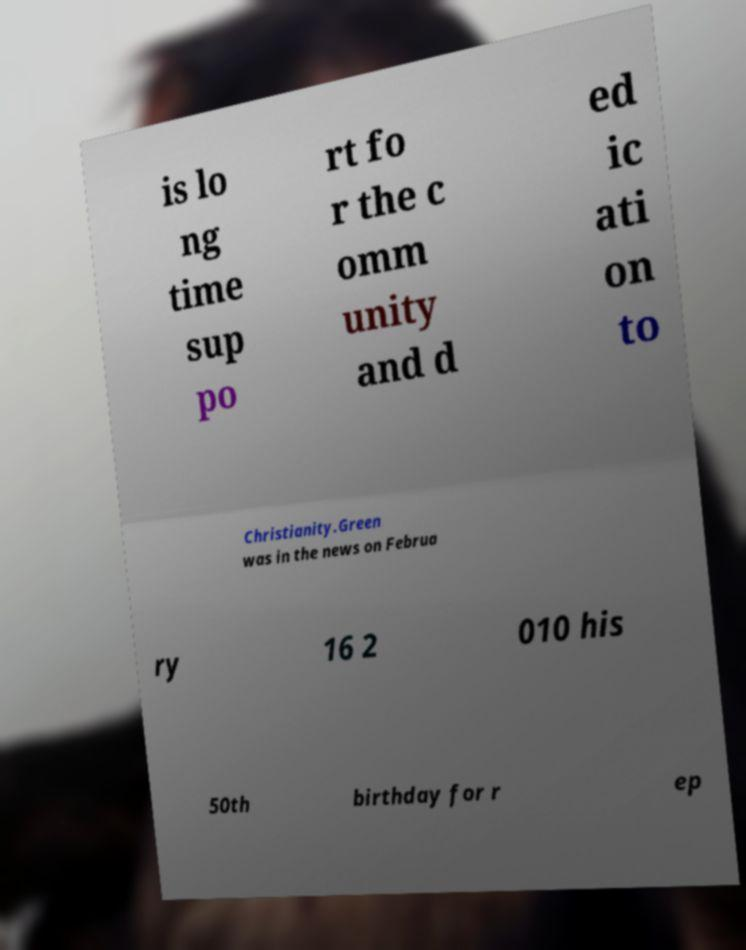Could you assist in decoding the text presented in this image and type it out clearly? is lo ng time sup po rt fo r the c omm unity and d ed ic ati on to Christianity.Green was in the news on Februa ry 16 2 010 his 50th birthday for r ep 